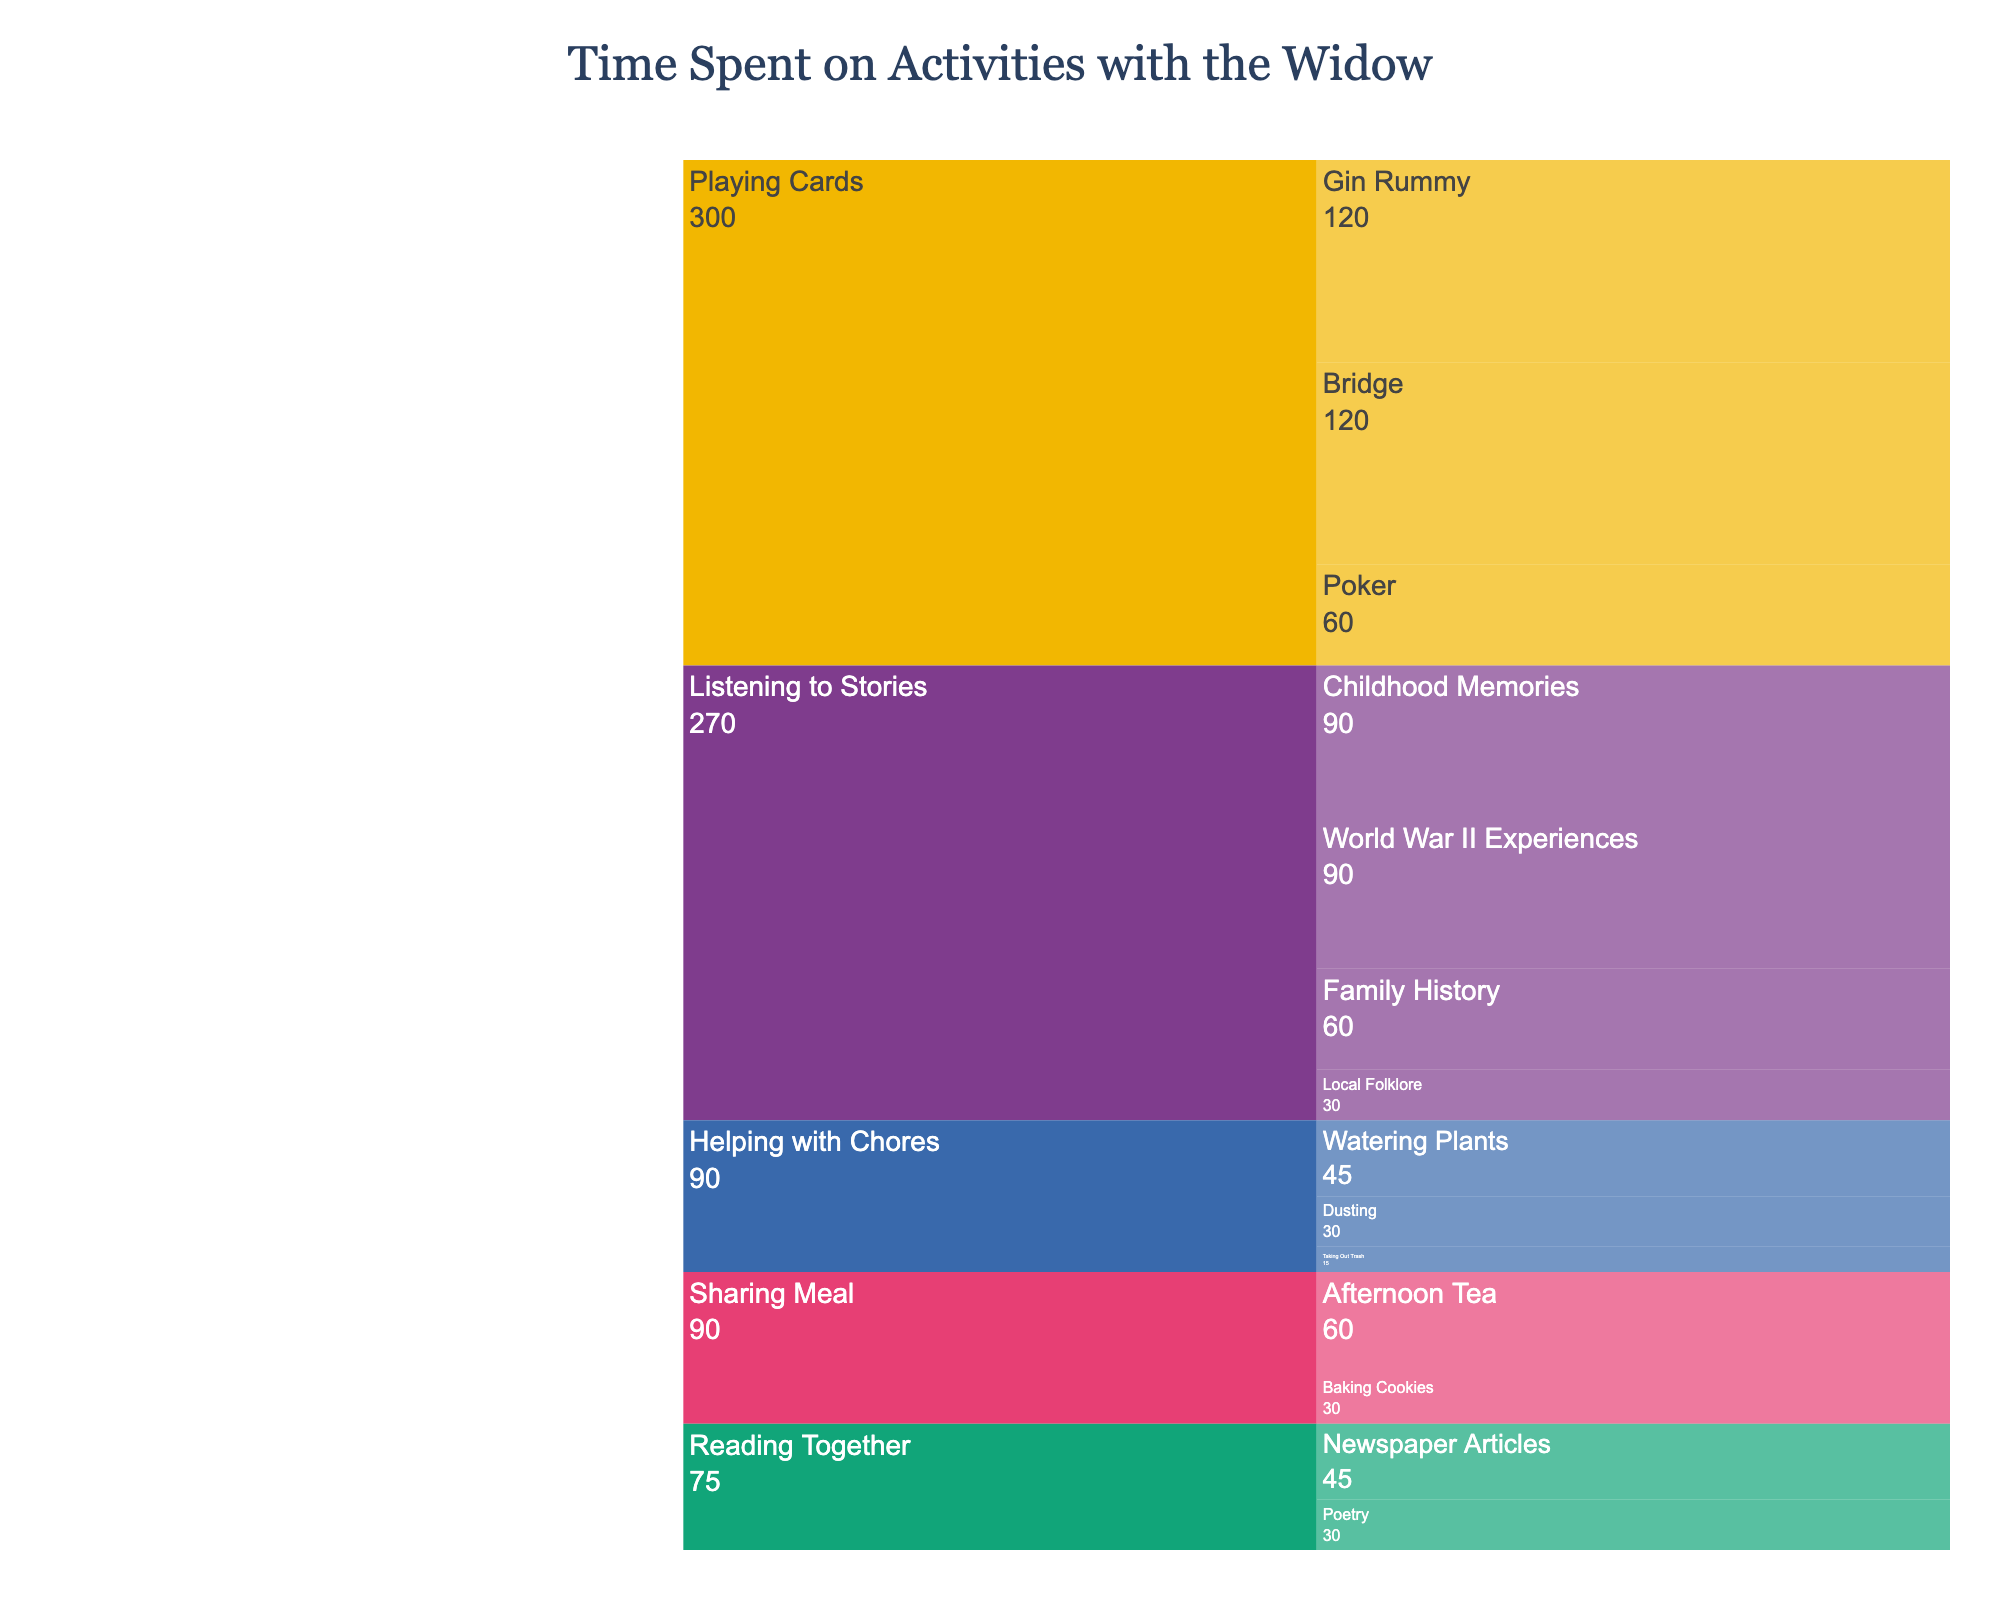What is the title of the chart? The title is prominently displayed at the top of the chart. It summarizes the purpose of the chart.
Answer: Time Spent on Activities with the Widow How many minutes are spent on playing Poker? The icicle chart will show the value associated with "Poker" under the main category "Playing Cards."
Answer: 60 Which activity has more sub-activities: Listening to Stories or Helping with Chores? Count the number of sub-activities listed under each main activity. "Listening to Stories" has more sub-activities than "Helping with Chores."
Answer: Listening to Stories What is the total time spent on Reading Together activities? Sum the time spent on each sub-activity under "Reading Together": 45 minutes (Newspaper Articles) + 30 minutes (Poetry).
Answer: 75 Which sub-activity under Sharing Meal takes the least amount of time? Compare the time values of the sub-activities under "Sharing Meal." "Baking Cookies" has fewer minutes than "Afternoon Tea."
Answer: Baking Cookies How much time is spent on Helping with Chores in total? Sum the time values for each sub-activity under "Helping with Chores": 45 minutes (Watering Plants) + 30 minutes (Dusting) + 15 minutes (Taking Out Trash).
Answer: 90 Which activity has the highest total time? Add up the time for all sub-activities within each activity. Comparing these totals, "Playing Cards" has the highest total time.
Answer: Playing Cards What percent of the total time is spent on Listening to Stories? First, sum up the total time spent on all activities. Then, sum the time spent on "Listening to Stories" and divide by the total time, multiplying by 100 to get the percentage. The calculation step-by-step is 270 minutes spent on "Listening to Stories." The total time for all activities is 795 minutes: 270/795 * 100.
Answer: Approximately 34% Which sub-activity under Listening to Stories takes the least amount of time? Compare the time values of the sub-activities under "Listening to Stories." "Local Folklore" has the least time.
Answer: Local Folklore Is more time spent on Reading Together or Sharing Meal? Sum the time values for each sub-activity under these categories. Compare these sums to find that "Reading Together" (75 minutes) is less than "Sharing Meal" (90 minutes).
Answer: Sharing Meal 